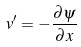<formula> <loc_0><loc_0><loc_500><loc_500>v ^ { \prime } = - \frac { \partial \psi } { \partial x }</formula> 